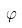Convert formula to latex. <formula><loc_0><loc_0><loc_500><loc_500>\varphi</formula> 